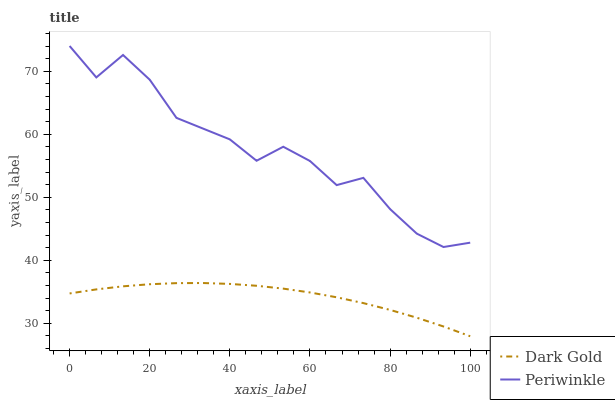Does Dark Gold have the maximum area under the curve?
Answer yes or no. No. Is Dark Gold the roughest?
Answer yes or no. No. Does Dark Gold have the highest value?
Answer yes or no. No. Is Dark Gold less than Periwinkle?
Answer yes or no. Yes. Is Periwinkle greater than Dark Gold?
Answer yes or no. Yes. Does Dark Gold intersect Periwinkle?
Answer yes or no. No. 